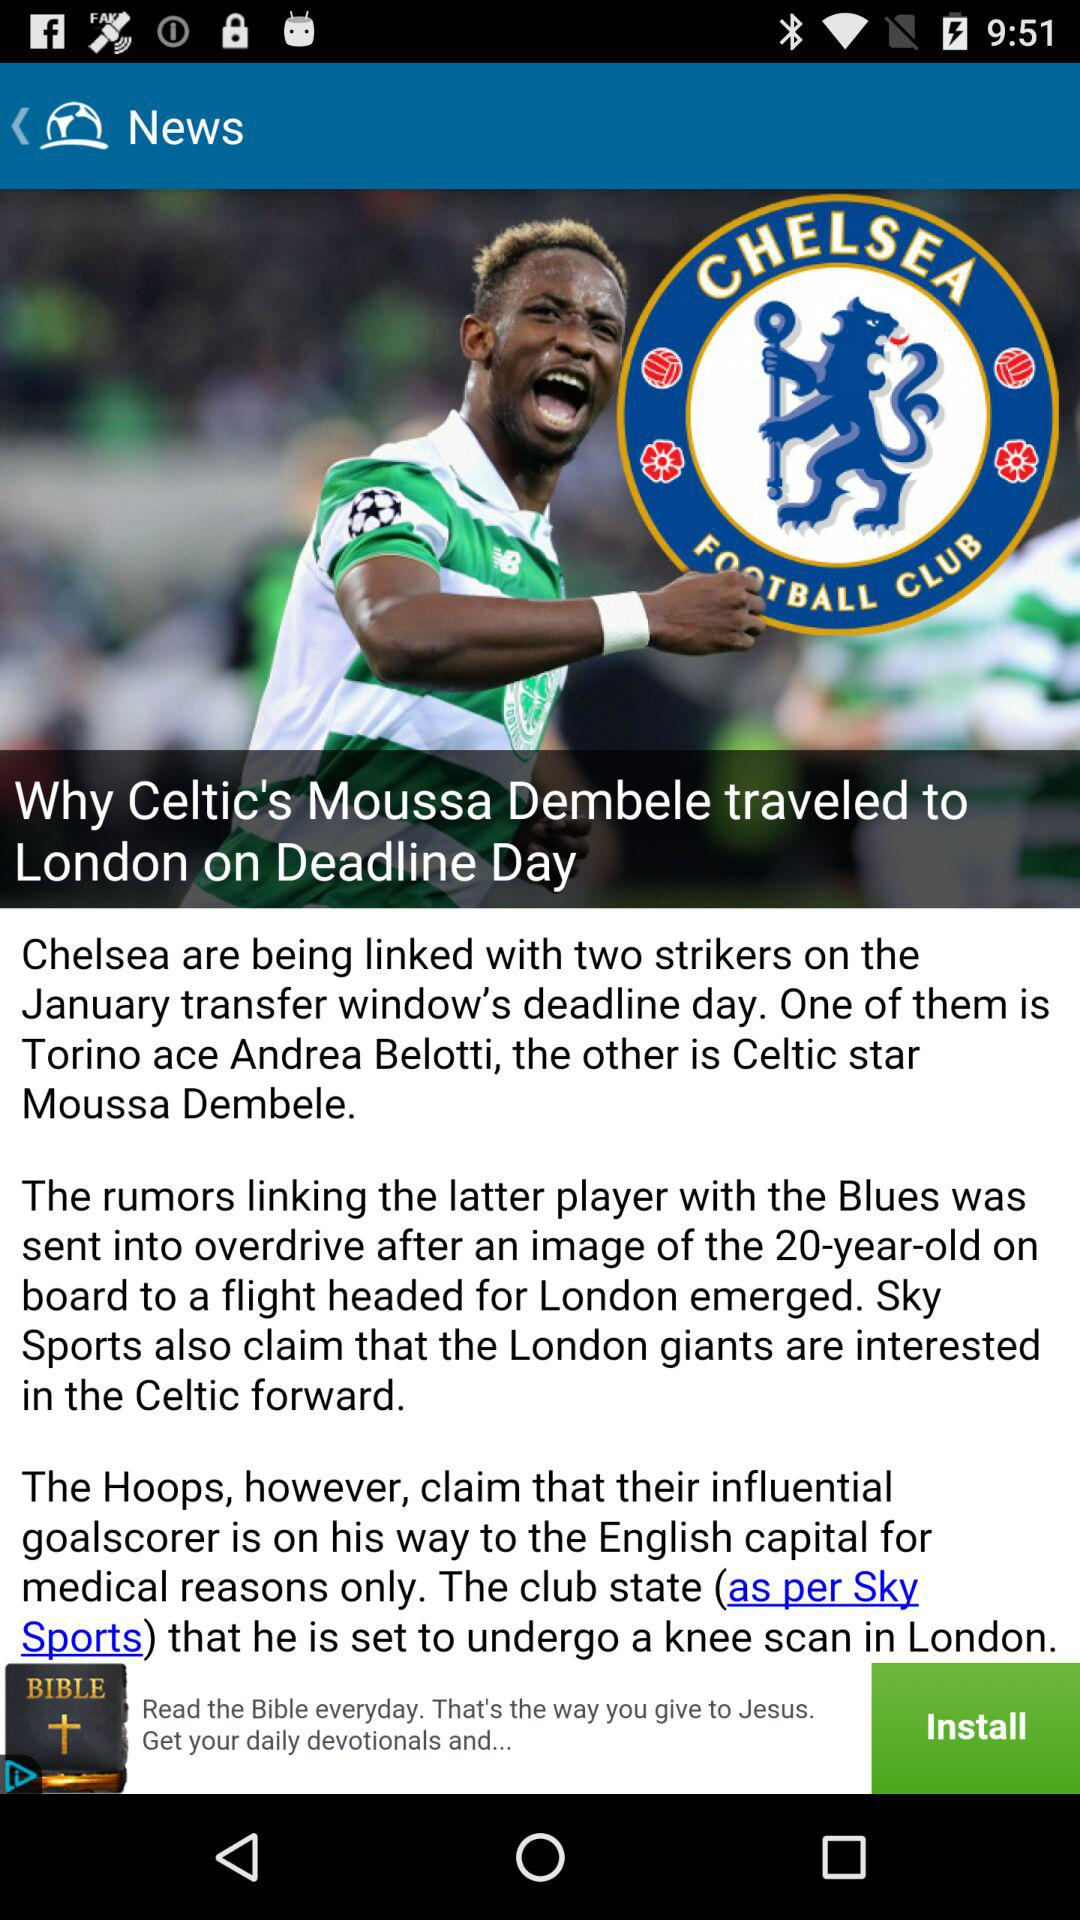Who is the author of the sports story?
When the provided information is insufficient, respond with <no answer>. <no answer> 